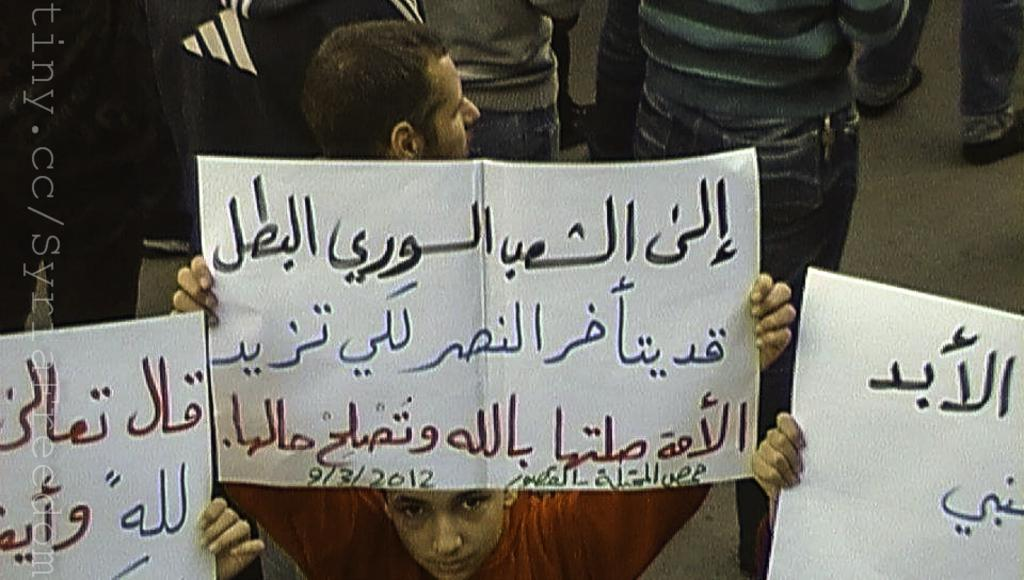How many people are in the image? There are people in the image, but the exact number is not specified. What are some of the people holding in the image? Some of the people are holding posters in the image. What type of skate is being used by the people in the image? There is no mention of skates or any skating activity in the image. 